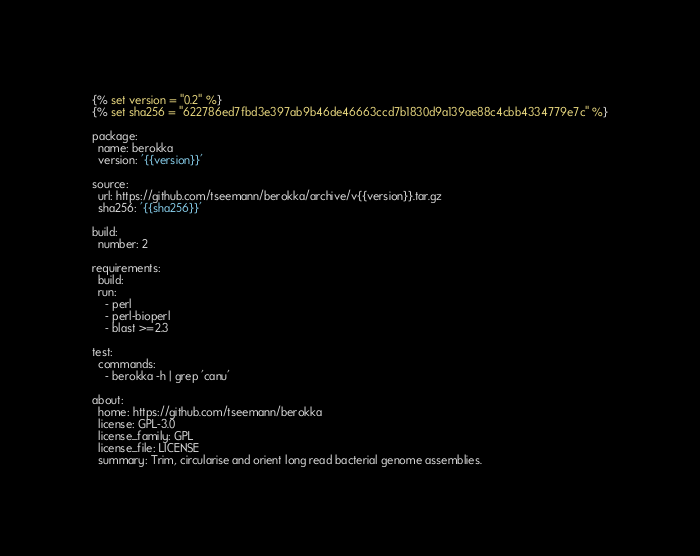Convert code to text. <code><loc_0><loc_0><loc_500><loc_500><_YAML_>{% set version = "0.2" %}
{% set sha256 = "622786ed7fbd3e397ab9b46de46663ccd7b1830d9a139ae88c4cbb4334779e7c" %}

package:
  name: berokka
  version: '{{version}}'

source:
  url: https://github.com/tseemann/berokka/archive/v{{version}}.tar.gz
  sha256: '{{sha256}}'

build:
  number: 2

requirements:
  build:
  run:
    - perl
    - perl-bioperl
    - blast >=2.3

test:
  commands:
    - berokka -h | grep 'canu'

about:
  home: https://github.com/tseemann/berokka
  license: GPL-3.0
  license_family: GPL
  license_file: LICENSE
  summary: Trim, circularise and orient long read bacterial genome assemblies.
</code> 